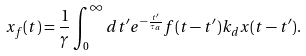Convert formula to latex. <formula><loc_0><loc_0><loc_500><loc_500>x _ { f } ( t ) = \frac { 1 } { \gamma } \int _ { 0 } ^ { \infty } d t ^ { \prime } e ^ { - \frac { t ^ { \prime } } { \tau _ { a } } } f ( t - t ^ { \prime } ) k _ { d } x ( t - t ^ { \prime } ) .</formula> 